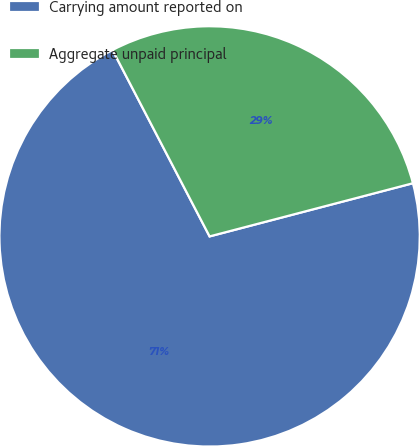Convert chart to OTSL. <chart><loc_0><loc_0><loc_500><loc_500><pie_chart><fcel>Carrying amount reported on<fcel>Aggregate unpaid principal<nl><fcel>71.43%<fcel>28.57%<nl></chart> 